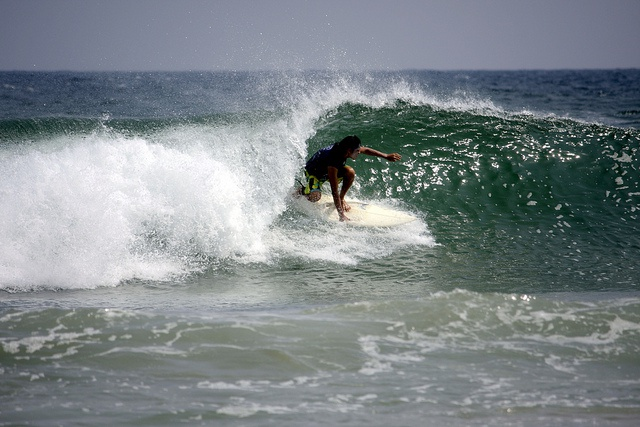Describe the objects in this image and their specific colors. I can see people in gray, black, maroon, and olive tones and surfboard in gray, beige, darkgray, and lightgray tones in this image. 